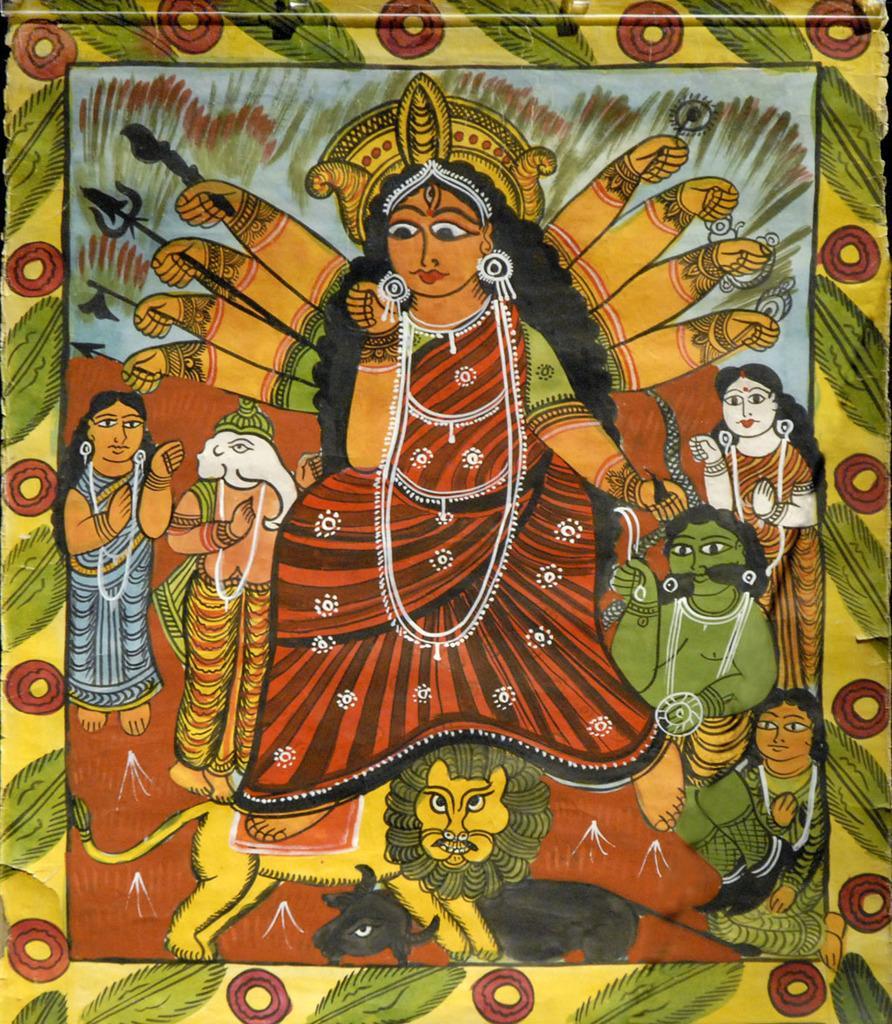Could you give a brief overview of what you see in this image? In the image in the center, we can see one frame. On the frame, we can see the painting of lord, few people, one lion and cow. 